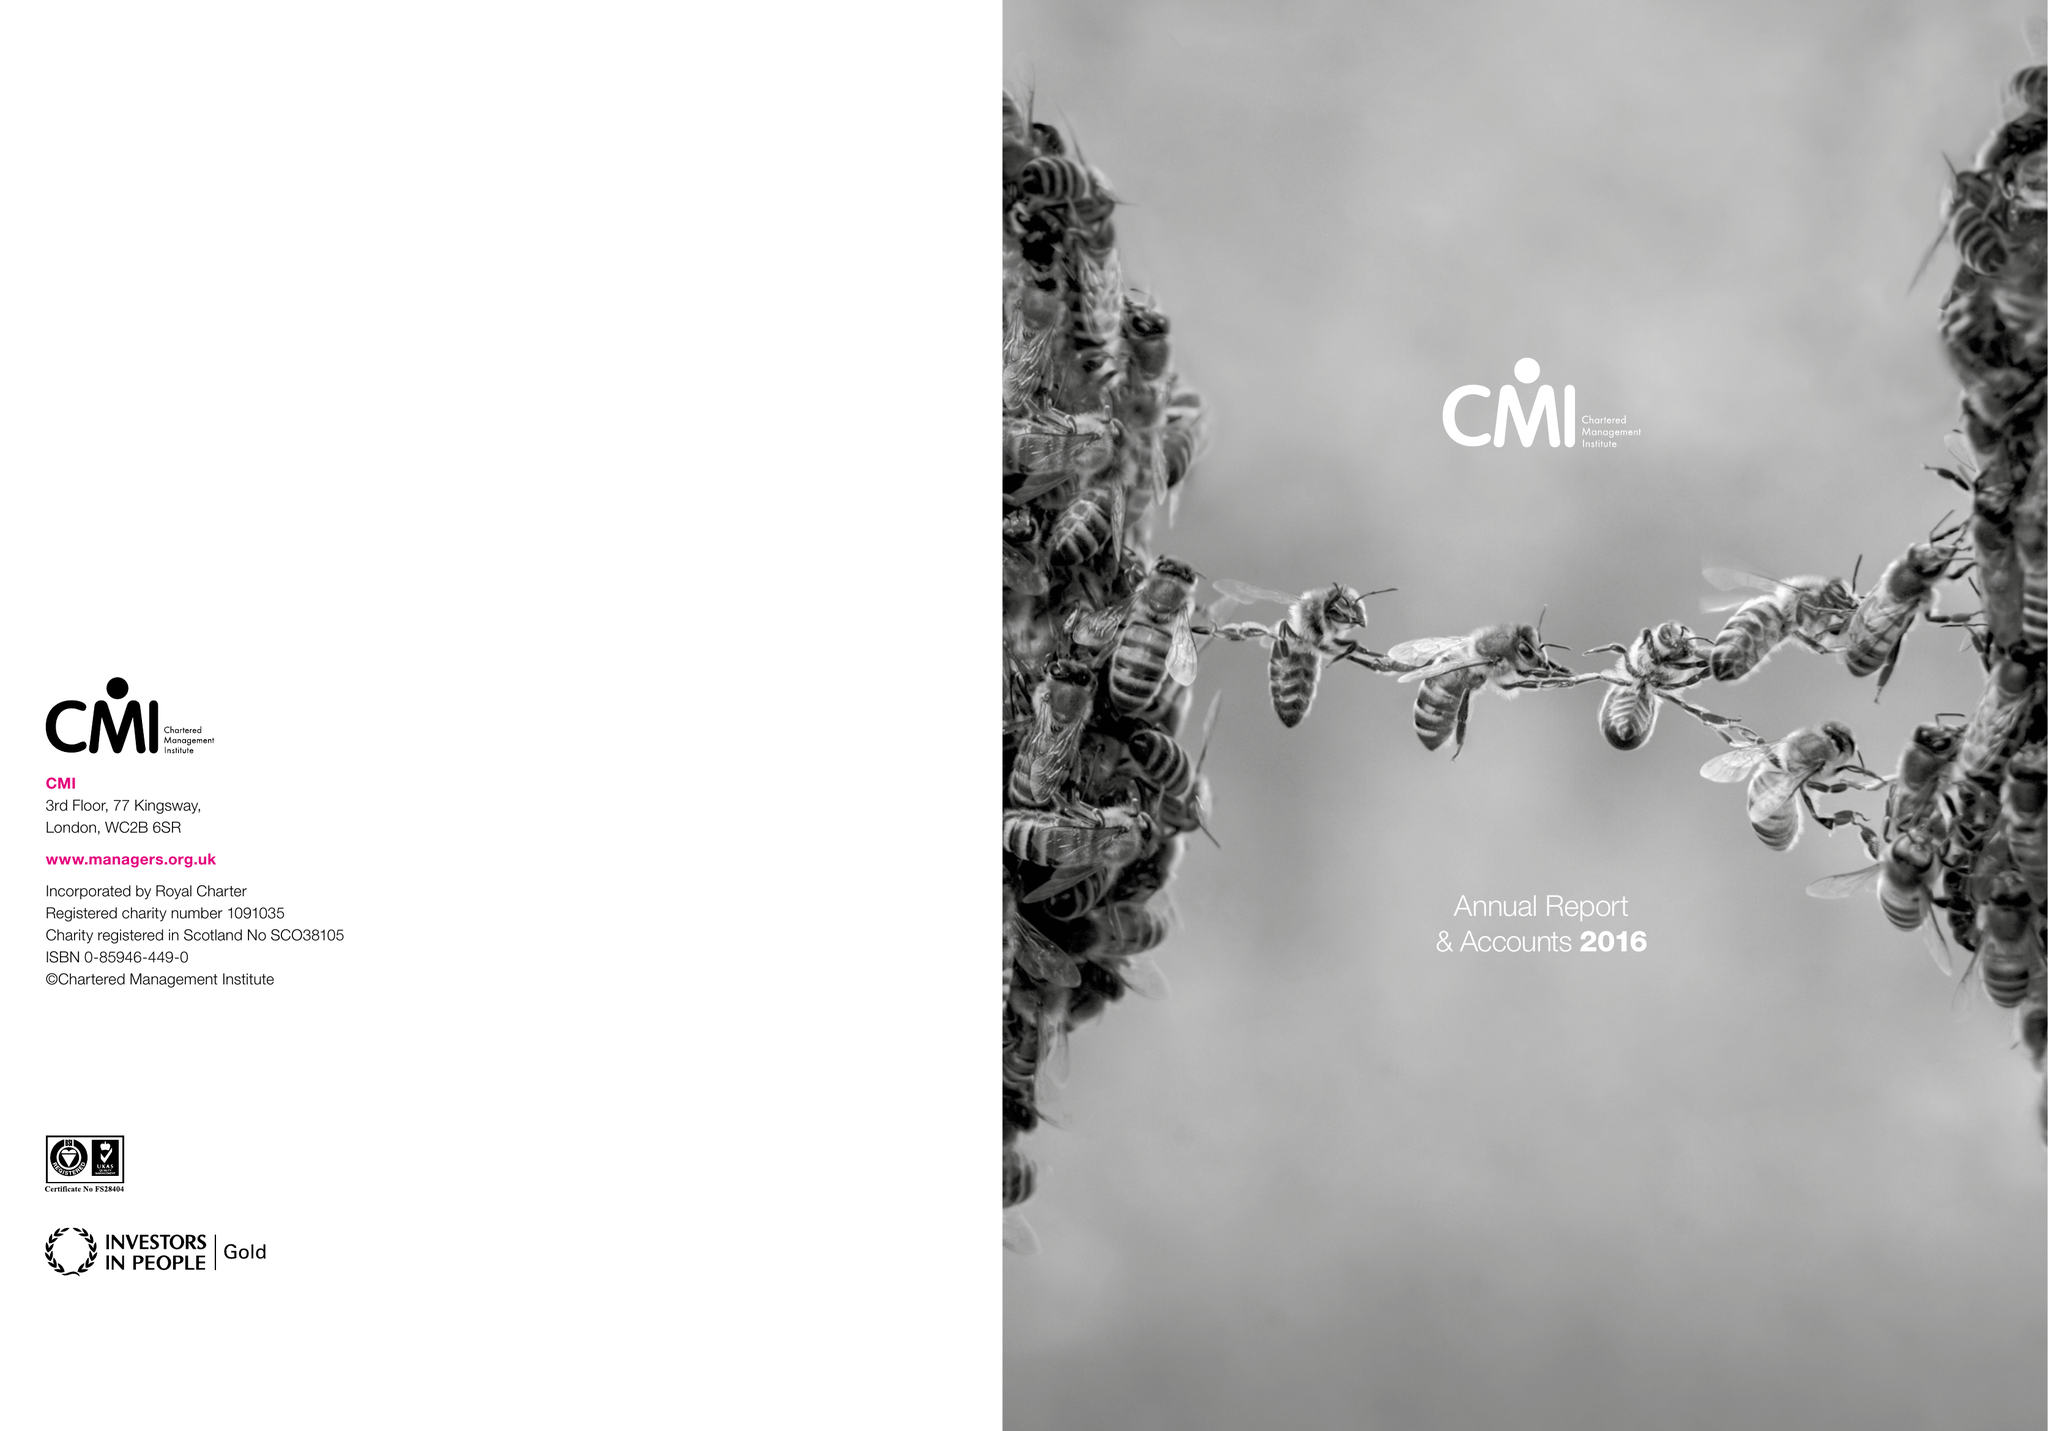What is the value for the address__post_town?
Answer the question using a single word or phrase. CORBY 